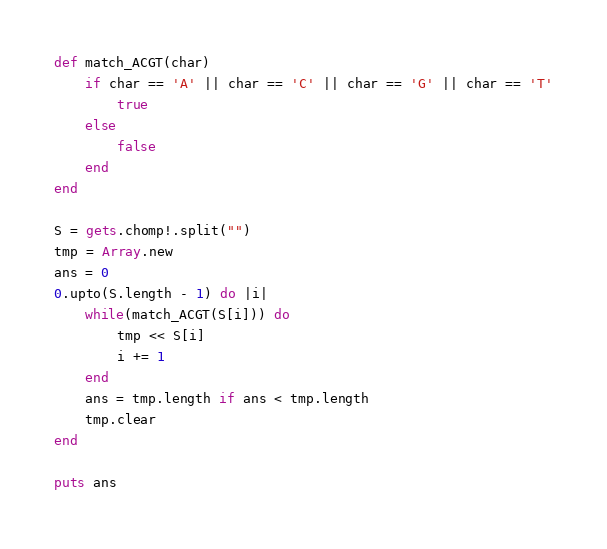Convert code to text. <code><loc_0><loc_0><loc_500><loc_500><_Ruby_>def match_ACGT(char)
    if char == 'A' || char == 'C' || char == 'G' || char == 'T'
        true
    else
        false
    end
end

S = gets.chomp!.split("")
tmp = Array.new
ans = 0
0.upto(S.length - 1) do |i|
    while(match_ACGT(S[i])) do 
        tmp << S[i]
        i += 1
    end
    ans = tmp.length if ans < tmp.length
    tmp.clear
end

puts ans</code> 